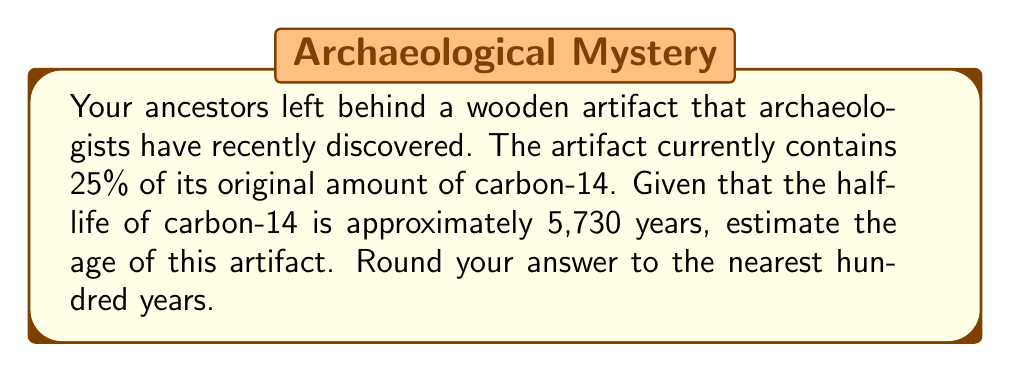Show me your answer to this math problem. To solve this problem, we'll use the radioactive decay formula and the concept of half-life. Let's break it down step-by-step:

1) The general formula for radioactive decay is:

   $$N(t) = N_0 \cdot (0.5)^{t/t_{1/2}}$$

   Where:
   $N(t)$ is the amount remaining after time $t$
   $N_0$ is the initial amount
   $t$ is the time elapsed
   $t_{1/2}$ is the half-life

2) We know that 25% of the original amount remains, so:

   $$0.25 = (0.5)^{t/5730}$$

3) To solve for $t$, we need to take the logarithm of both sides:

   $$\log(0.25) = \log((0.5)^{t/5730})$$

4) Using the logarithm property $\log(a^b) = b\log(a)$:

   $$\log(0.25) = \frac{t}{5730} \cdot \log(0.5)$$

5) Solve for $t$:

   $$t = 5730 \cdot \frac{\log(0.25)}{\log(0.5)}$$

6) Calculate:

   $$t \approx 11,460.5$$

7) Rounding to the nearest hundred years:

   $$t \approx 11,500 \text{ years}$$
Answer: The estimated age of the artifact is approximately 11,500 years. 